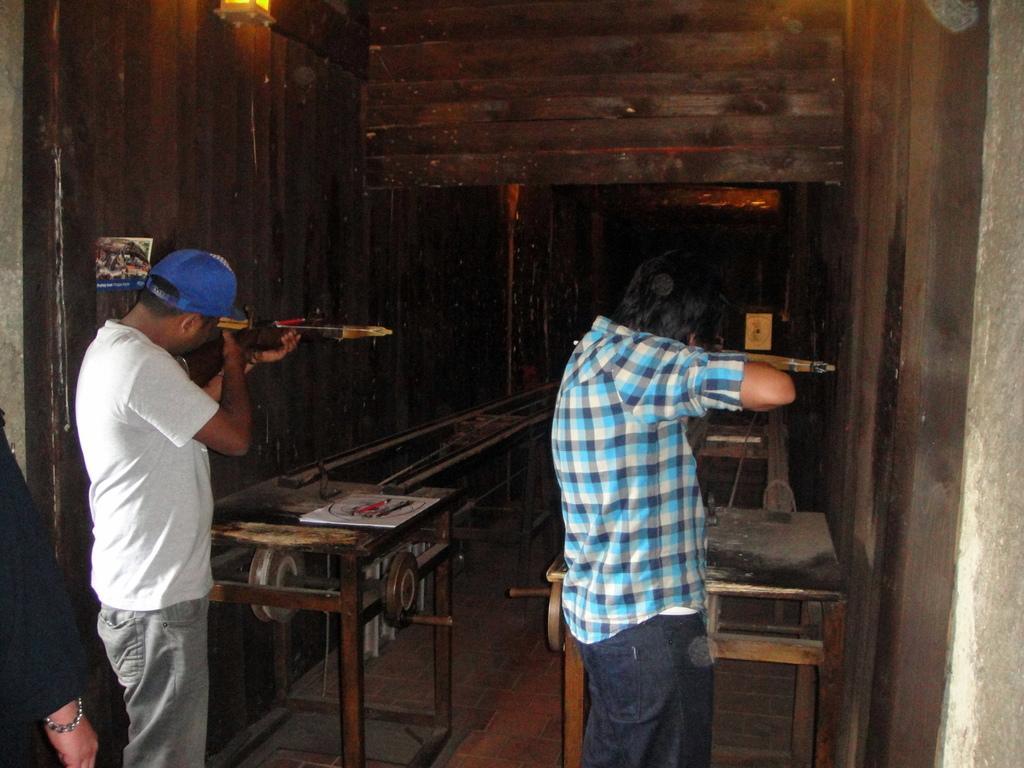How would you summarize this image in a sentence or two? In this image, we can see two men standing and they are holding objects in the hand, we can see tables and walls. 